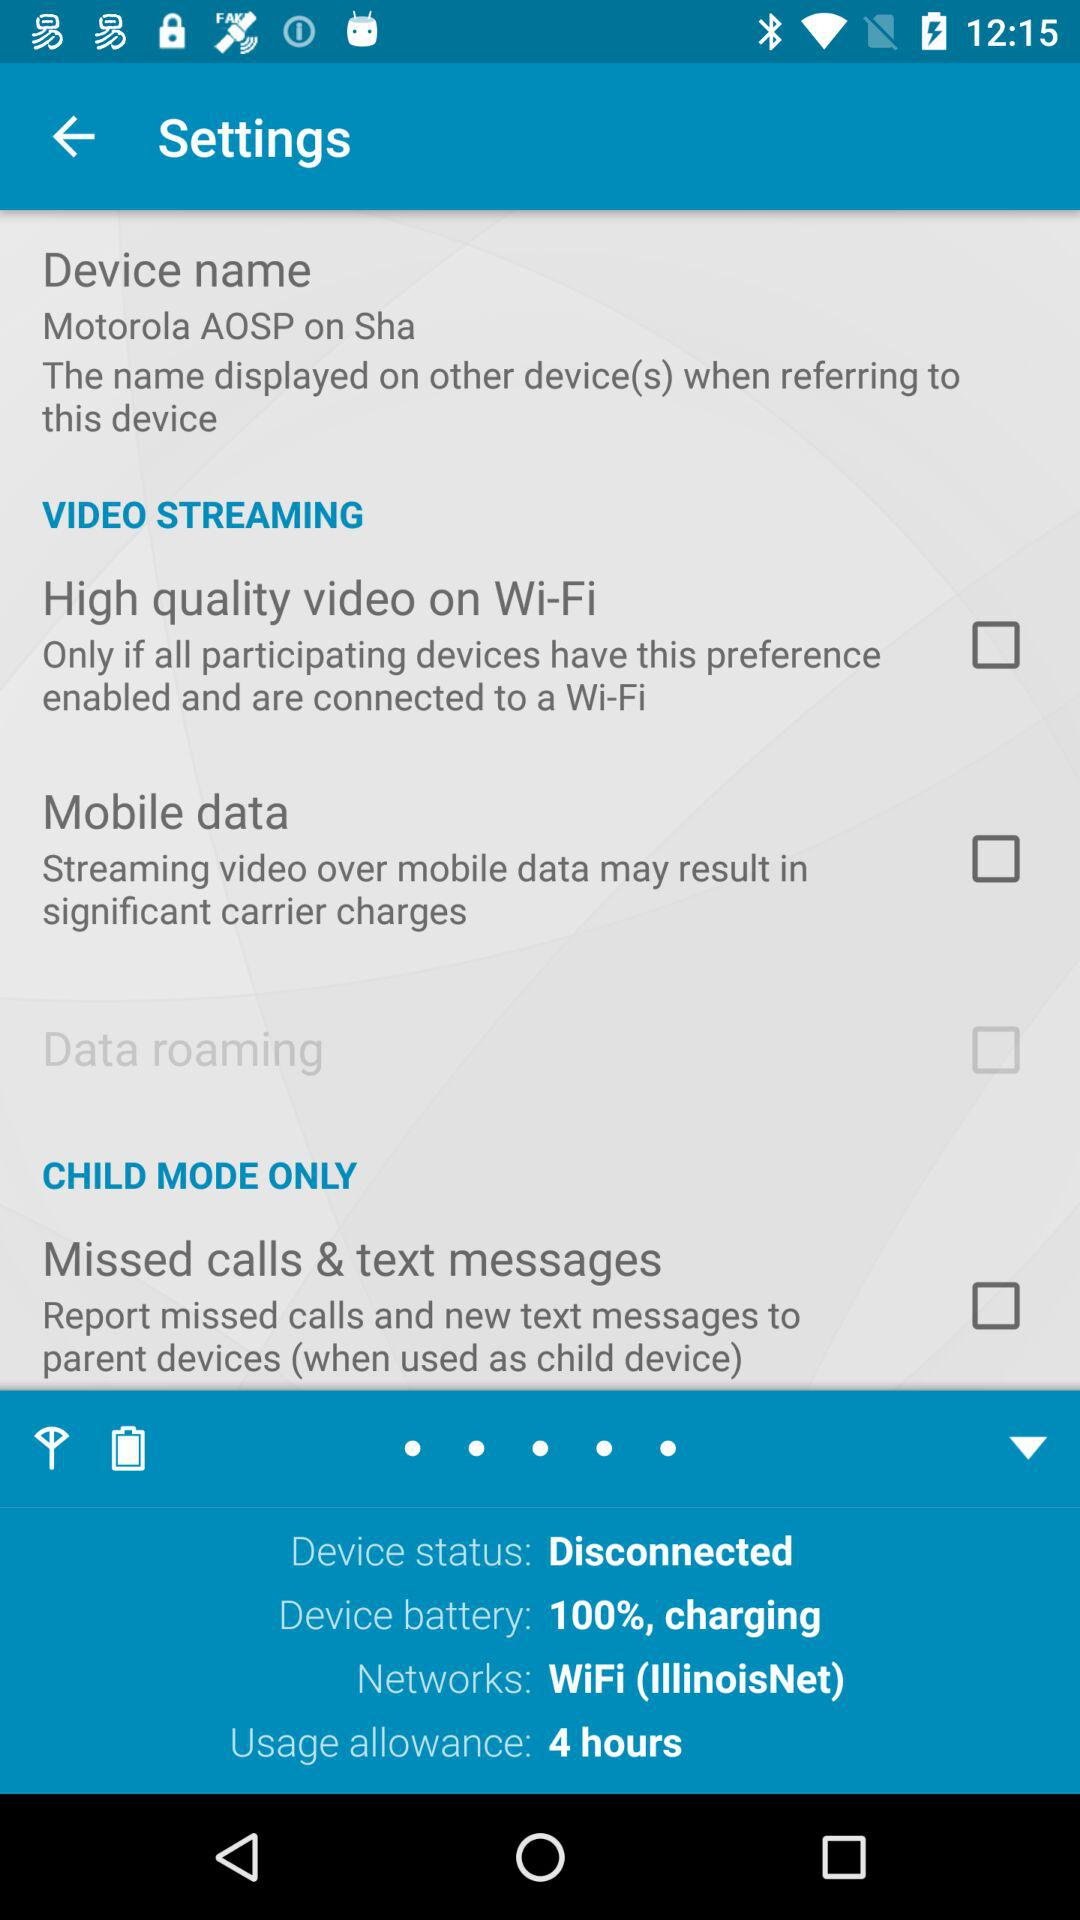Through what network device is connected? The device is connected through "WiFi (IllinoisNet)". 